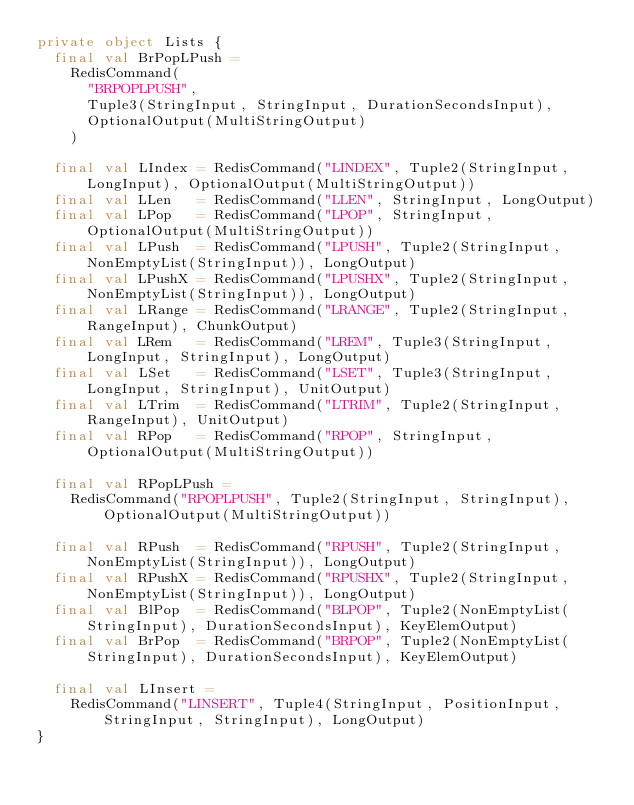<code> <loc_0><loc_0><loc_500><loc_500><_Scala_>private object Lists {
  final val BrPopLPush =
    RedisCommand(
      "BRPOPLPUSH",
      Tuple3(StringInput, StringInput, DurationSecondsInput),
      OptionalOutput(MultiStringOutput)
    )

  final val LIndex = RedisCommand("LINDEX", Tuple2(StringInput, LongInput), OptionalOutput(MultiStringOutput))
  final val LLen   = RedisCommand("LLEN", StringInput, LongOutput)
  final val LPop   = RedisCommand("LPOP", StringInput, OptionalOutput(MultiStringOutput))
  final val LPush  = RedisCommand("LPUSH", Tuple2(StringInput, NonEmptyList(StringInput)), LongOutput)
  final val LPushX = RedisCommand("LPUSHX", Tuple2(StringInput, NonEmptyList(StringInput)), LongOutput)
  final val LRange = RedisCommand("LRANGE", Tuple2(StringInput, RangeInput), ChunkOutput)
  final val LRem   = RedisCommand("LREM", Tuple3(StringInput, LongInput, StringInput), LongOutput)
  final val LSet   = RedisCommand("LSET", Tuple3(StringInput, LongInput, StringInput), UnitOutput)
  final val LTrim  = RedisCommand("LTRIM", Tuple2(StringInput, RangeInput), UnitOutput)
  final val RPop   = RedisCommand("RPOP", StringInput, OptionalOutput(MultiStringOutput))

  final val RPopLPush =
    RedisCommand("RPOPLPUSH", Tuple2(StringInput, StringInput), OptionalOutput(MultiStringOutput))

  final val RPush  = RedisCommand("RPUSH", Tuple2(StringInput, NonEmptyList(StringInput)), LongOutput)
  final val RPushX = RedisCommand("RPUSHX", Tuple2(StringInput, NonEmptyList(StringInput)), LongOutput)
  final val BlPop  = RedisCommand("BLPOP", Tuple2(NonEmptyList(StringInput), DurationSecondsInput), KeyElemOutput)
  final val BrPop  = RedisCommand("BRPOP", Tuple2(NonEmptyList(StringInput), DurationSecondsInput), KeyElemOutput)

  final val LInsert =
    RedisCommand("LINSERT", Tuple4(StringInput, PositionInput, StringInput, StringInput), LongOutput)
}
</code> 